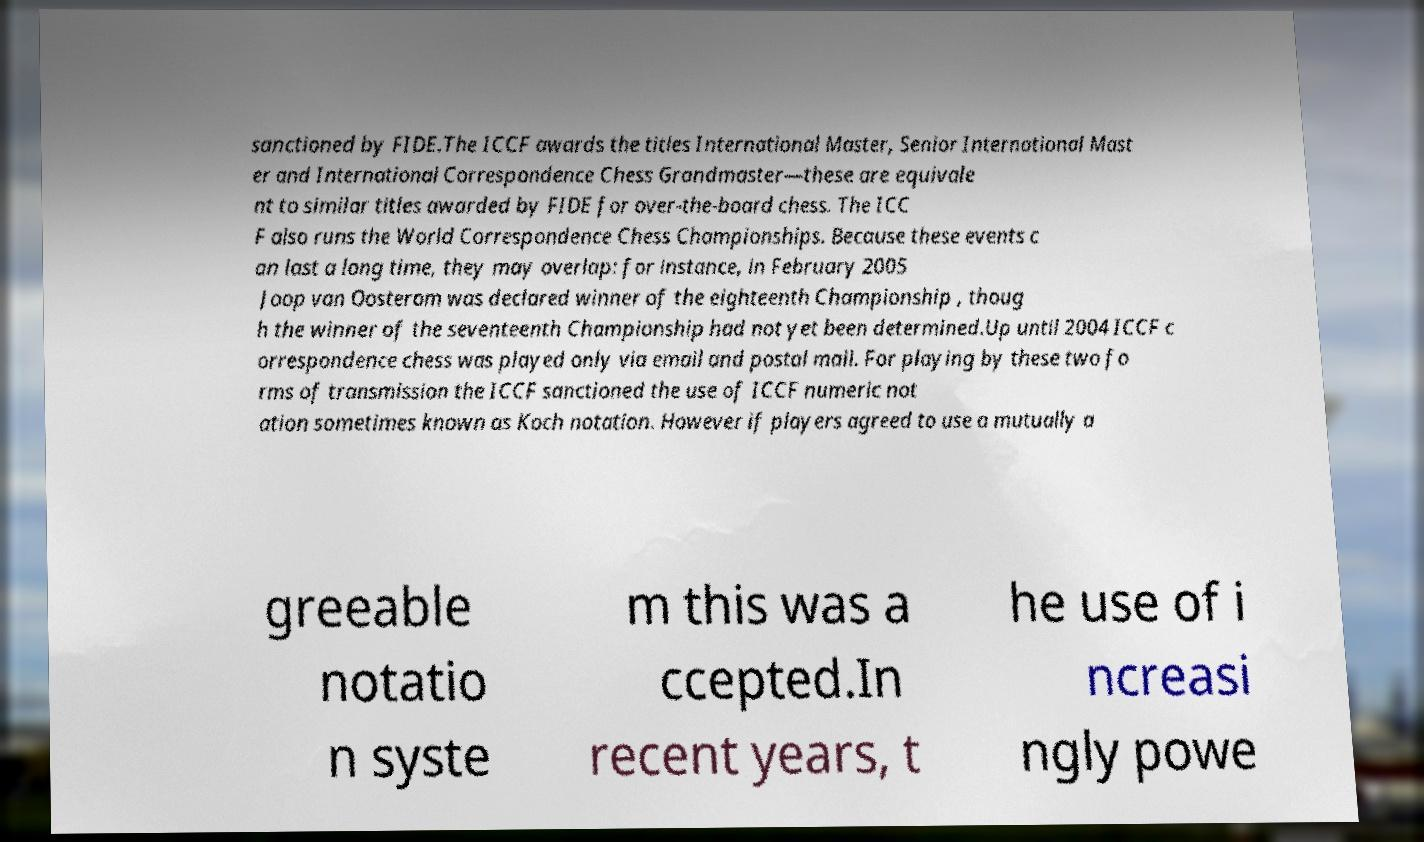There's text embedded in this image that I need extracted. Can you transcribe it verbatim? sanctioned by FIDE.The ICCF awards the titles International Master, Senior International Mast er and International Correspondence Chess Grandmaster—these are equivale nt to similar titles awarded by FIDE for over-the-board chess. The ICC F also runs the World Correspondence Chess Championships. Because these events c an last a long time, they may overlap: for instance, in February 2005 Joop van Oosterom was declared winner of the eighteenth Championship , thoug h the winner of the seventeenth Championship had not yet been determined.Up until 2004 ICCF c orrespondence chess was played only via email and postal mail. For playing by these two fo rms of transmission the ICCF sanctioned the use of ICCF numeric not ation sometimes known as Koch notation. However if players agreed to use a mutually a greeable notatio n syste m this was a ccepted.In recent years, t he use of i ncreasi ngly powe 